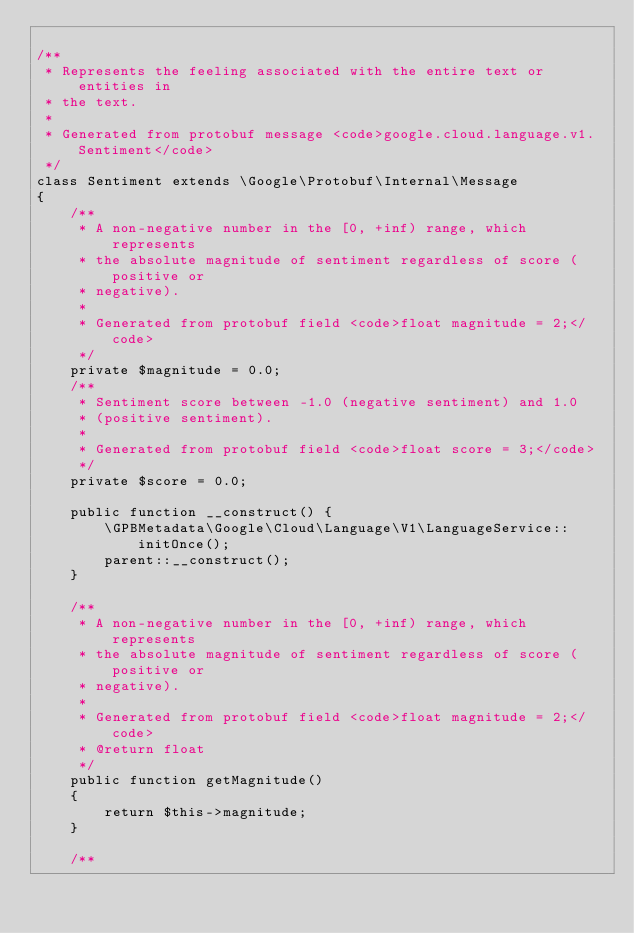Convert code to text. <code><loc_0><loc_0><loc_500><loc_500><_PHP_>
/**
 * Represents the feeling associated with the entire text or entities in
 * the text.
 *
 * Generated from protobuf message <code>google.cloud.language.v1.Sentiment</code>
 */
class Sentiment extends \Google\Protobuf\Internal\Message
{
    /**
     * A non-negative number in the [0, +inf) range, which represents
     * the absolute magnitude of sentiment regardless of score (positive or
     * negative).
     *
     * Generated from protobuf field <code>float magnitude = 2;</code>
     */
    private $magnitude = 0.0;
    /**
     * Sentiment score between -1.0 (negative sentiment) and 1.0
     * (positive sentiment).
     *
     * Generated from protobuf field <code>float score = 3;</code>
     */
    private $score = 0.0;

    public function __construct() {
        \GPBMetadata\Google\Cloud\Language\V1\LanguageService::initOnce();
        parent::__construct();
    }

    /**
     * A non-negative number in the [0, +inf) range, which represents
     * the absolute magnitude of sentiment regardless of score (positive or
     * negative).
     *
     * Generated from protobuf field <code>float magnitude = 2;</code>
     * @return float
     */
    public function getMagnitude()
    {
        return $this->magnitude;
    }

    /**</code> 